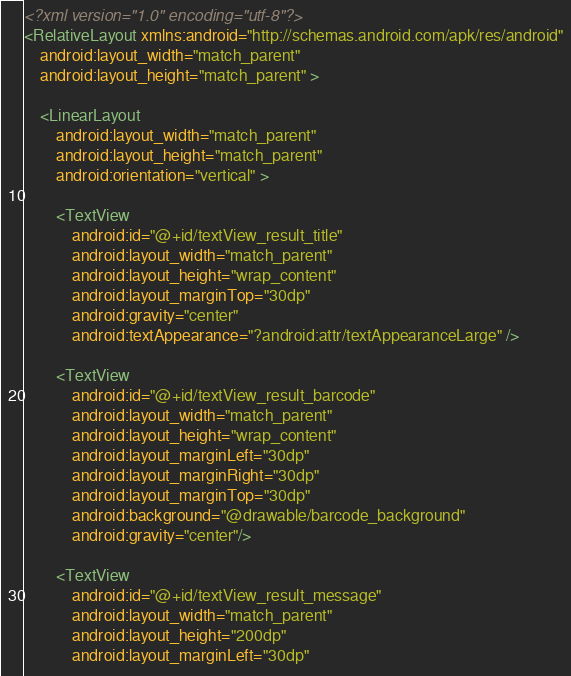<code> <loc_0><loc_0><loc_500><loc_500><_XML_><?xml version="1.0" encoding="utf-8"?>
<RelativeLayout xmlns:android="http://schemas.android.com/apk/res/android"
    android:layout_width="match_parent"
    android:layout_height="match_parent" >

    <LinearLayout
        android:layout_width="match_parent"
        android:layout_height="match_parent"
        android:orientation="vertical" >

        <TextView
            android:id="@+id/textView_result_title"
            android:layout_width="match_parent"
            android:layout_height="wrap_content"
            android:layout_marginTop="30dp"
            android:gravity="center"
            android:textAppearance="?android:attr/textAppearanceLarge" />

        <TextView
            android:id="@+id/textView_result_barcode"
            android:layout_width="match_parent"
            android:layout_height="wrap_content"
            android:layout_marginLeft="30dp"
            android:layout_marginRight="30dp"
            android:layout_marginTop="30dp"
            android:background="@drawable/barcode_background"
            android:gravity="center"/>

        <TextView
            android:id="@+id/textView_result_message"
            android:layout_width="match_parent"
            android:layout_height="200dp"
            android:layout_marginLeft="30dp"</code> 